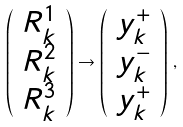<formula> <loc_0><loc_0><loc_500><loc_500>\left ( \begin{array} [ c ] { c } R _ { k } ^ { 1 } \\ R _ { k } ^ { 2 } \\ R _ { k } ^ { 3 } \end{array} \right ) \rightarrow \left ( \begin{array} [ c ] { c } y _ { k } ^ { + } \\ y _ { k } ^ { - } \\ y _ { k } ^ { + } \end{array} \right ) \, ,</formula> 